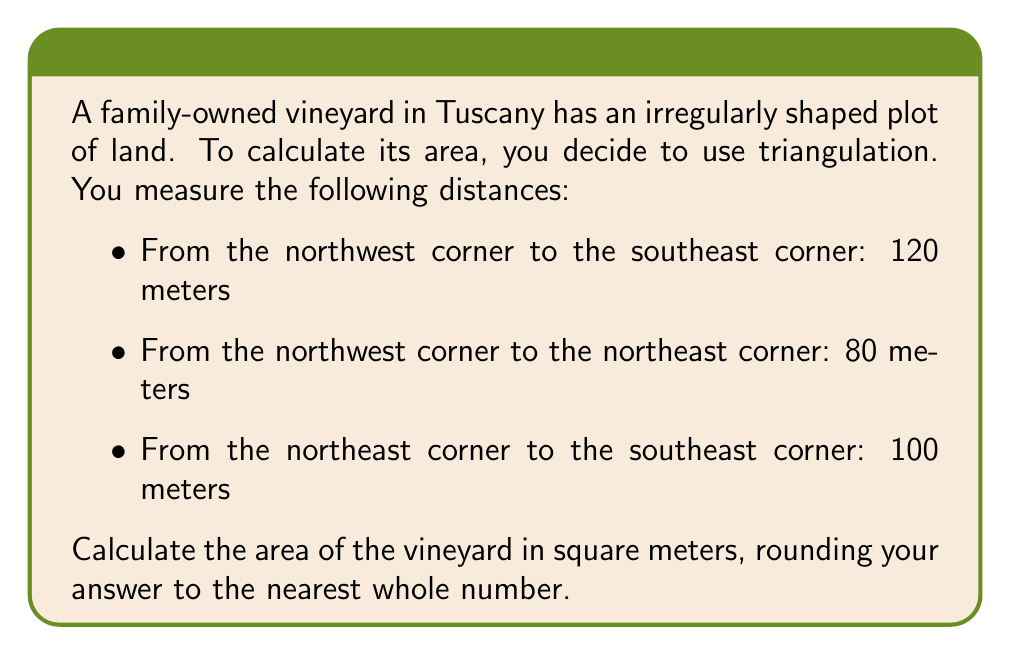Teach me how to tackle this problem. Let's approach this step-by-step using Heron's formula:

1) First, we need to recall Heron's formula for the area of a triangle:
   $$A = \sqrt{s(s-a)(s-b)(s-c)}$$
   where $s$ is the semi-perimeter, and $a$, $b$, and $c$ are the side lengths.

2) We have the following side lengths:
   $a = 120$ m (NW to SE)
   $b = 80$ m (NW to NE)
   $c = 100$ m (NE to SE)

3) Calculate the semi-perimeter $s$:
   $$s = \frac{a + b + c}{2} = \frac{120 + 80 + 100}{2} = 150$$ m

4) Now we can substitute these values into Heron's formula:
   $$A = \sqrt{150(150-120)(150-80)(150-100)}$$
   $$A = \sqrt{150 \cdot 30 \cdot 70 \cdot 50}$$
   $$A = \sqrt{15,750,000}$$

5) Simplify:
   $$A \approx 3,968.63$$ sq m

6) Rounding to the nearest whole number:
   $$A \approx 3,969$$ sq m
Answer: 3,969 sq m 